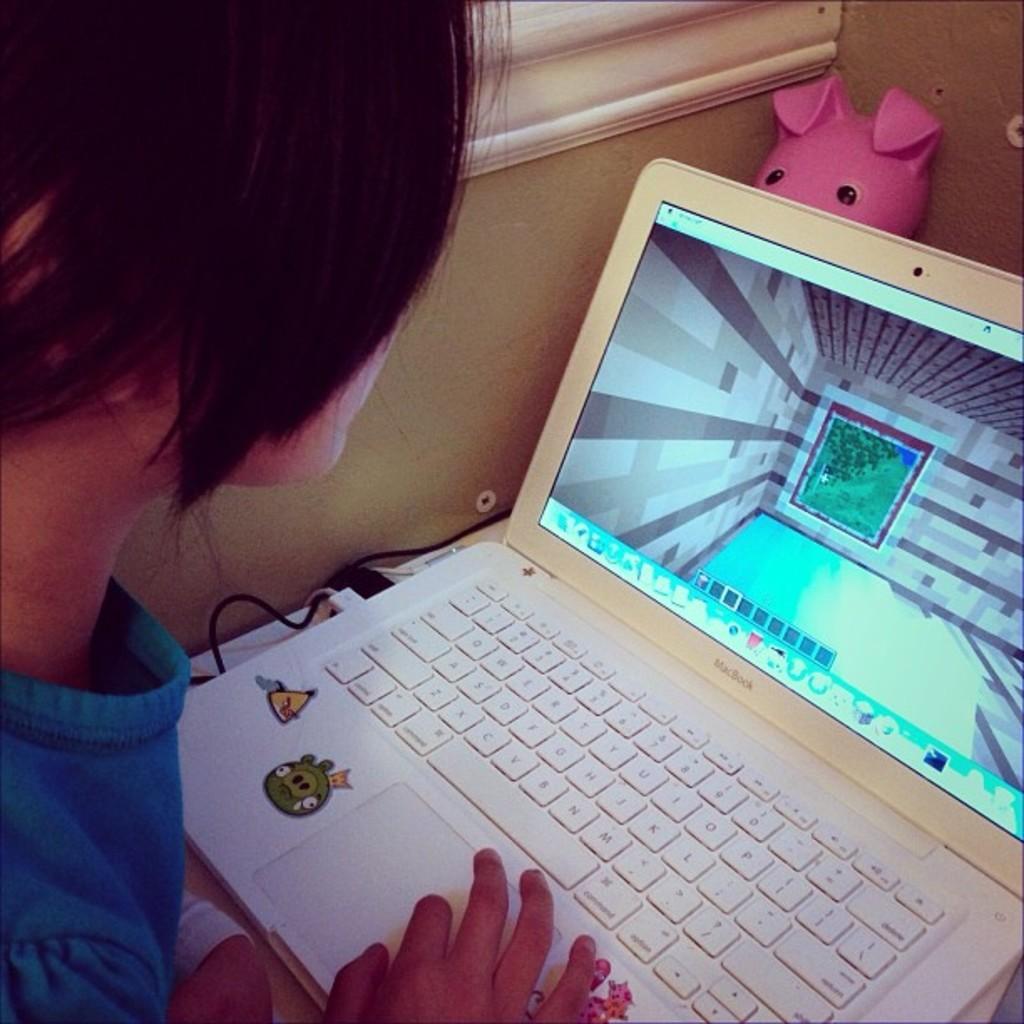Could you give a brief overview of what you see in this image? In this image I can see a person, laptop, toy, wire, window and wall. This image is taken may be in a room. 